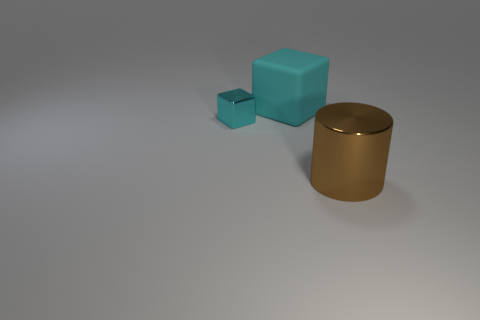Add 1 tiny shiny cylinders. How many objects exist? 4 Subtract all cylinders. How many objects are left? 2 Add 3 big objects. How many big objects are left? 5 Add 3 cyan metal cubes. How many cyan metal cubes exist? 4 Subtract 1 brown cylinders. How many objects are left? 2 Subtract all cyan rubber cubes. Subtract all cyan matte cubes. How many objects are left? 1 